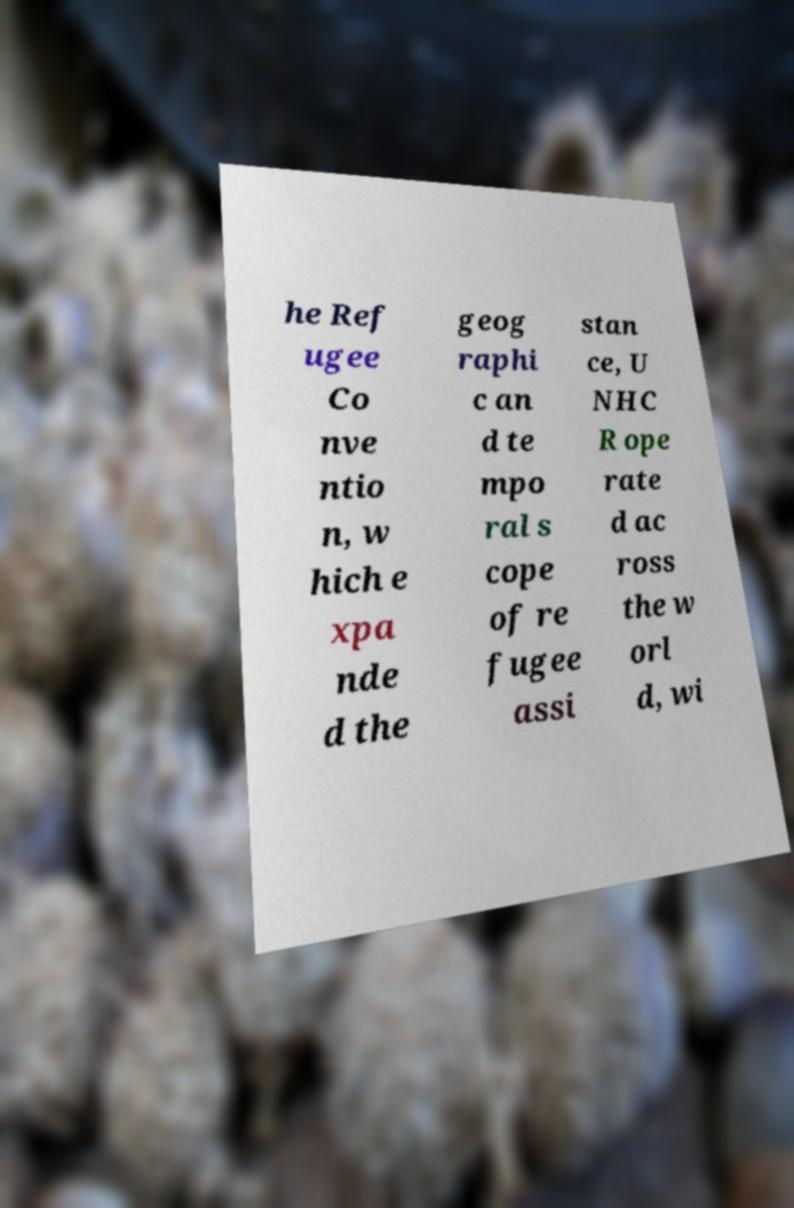There's text embedded in this image that I need extracted. Can you transcribe it verbatim? he Ref ugee Co nve ntio n, w hich e xpa nde d the geog raphi c an d te mpo ral s cope of re fugee assi stan ce, U NHC R ope rate d ac ross the w orl d, wi 